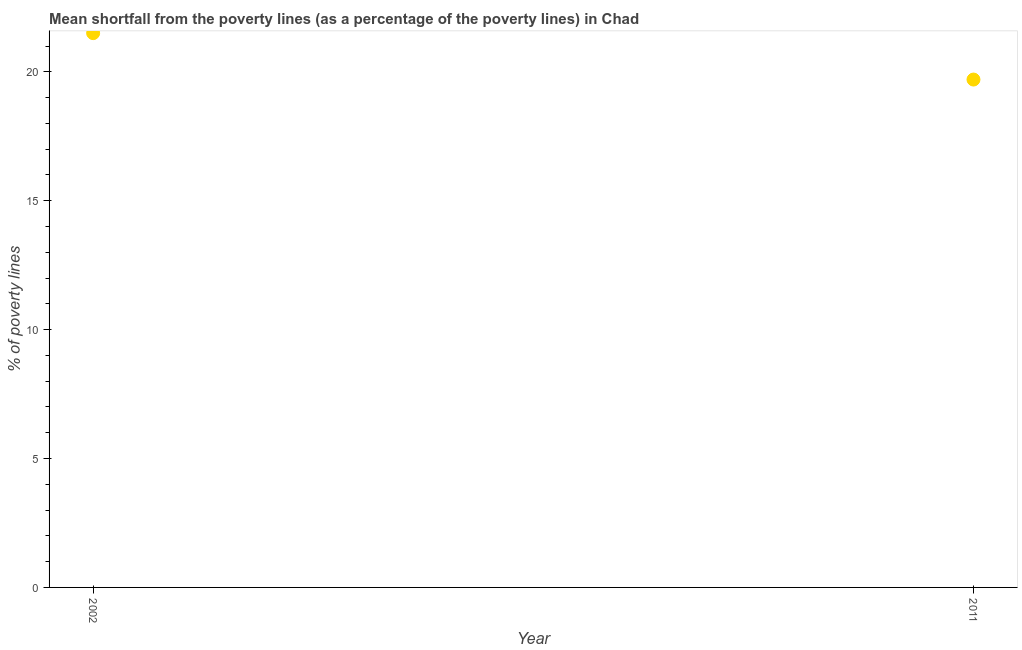Across all years, what is the maximum poverty gap at national poverty lines?
Ensure brevity in your answer.  21.5. Across all years, what is the minimum poverty gap at national poverty lines?
Ensure brevity in your answer.  19.7. In which year was the poverty gap at national poverty lines maximum?
Provide a succinct answer. 2002. What is the sum of the poverty gap at national poverty lines?
Make the answer very short. 41.2. What is the difference between the poverty gap at national poverty lines in 2002 and 2011?
Your response must be concise. 1.8. What is the average poverty gap at national poverty lines per year?
Your answer should be very brief. 20.6. What is the median poverty gap at national poverty lines?
Your answer should be compact. 20.6. In how many years, is the poverty gap at national poverty lines greater than 18 %?
Keep it short and to the point. 2. What is the ratio of the poverty gap at national poverty lines in 2002 to that in 2011?
Keep it short and to the point. 1.09. In how many years, is the poverty gap at national poverty lines greater than the average poverty gap at national poverty lines taken over all years?
Make the answer very short. 1. Does the poverty gap at national poverty lines monotonically increase over the years?
Provide a short and direct response. No. Does the graph contain any zero values?
Your response must be concise. No. What is the title of the graph?
Give a very brief answer. Mean shortfall from the poverty lines (as a percentage of the poverty lines) in Chad. What is the label or title of the Y-axis?
Offer a very short reply. % of poverty lines. What is the % of poverty lines in 2002?
Make the answer very short. 21.5. What is the difference between the % of poverty lines in 2002 and 2011?
Provide a short and direct response. 1.8. What is the ratio of the % of poverty lines in 2002 to that in 2011?
Offer a terse response. 1.09. 